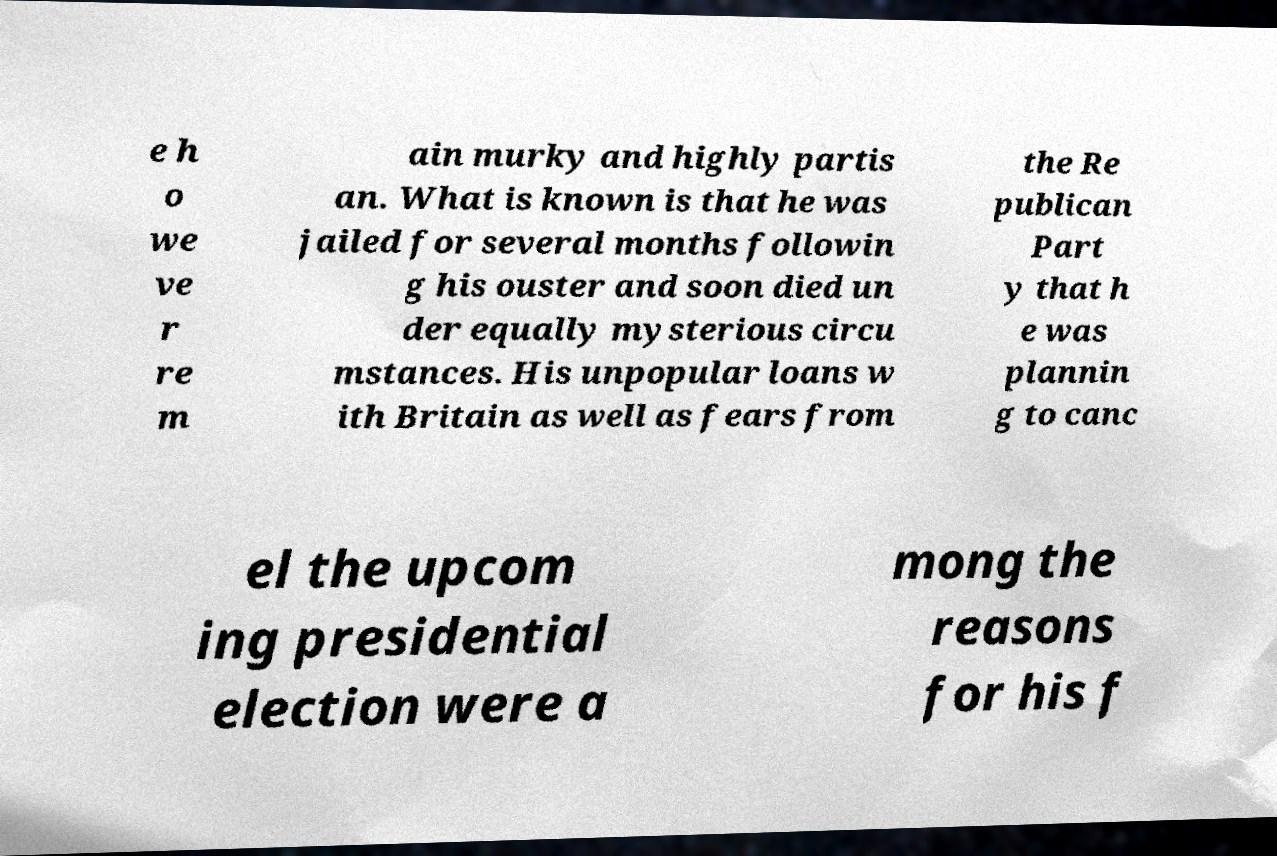Please read and relay the text visible in this image. What does it say? e h o we ve r re m ain murky and highly partis an. What is known is that he was jailed for several months followin g his ouster and soon died un der equally mysterious circu mstances. His unpopular loans w ith Britain as well as fears from the Re publican Part y that h e was plannin g to canc el the upcom ing presidential election were a mong the reasons for his f 